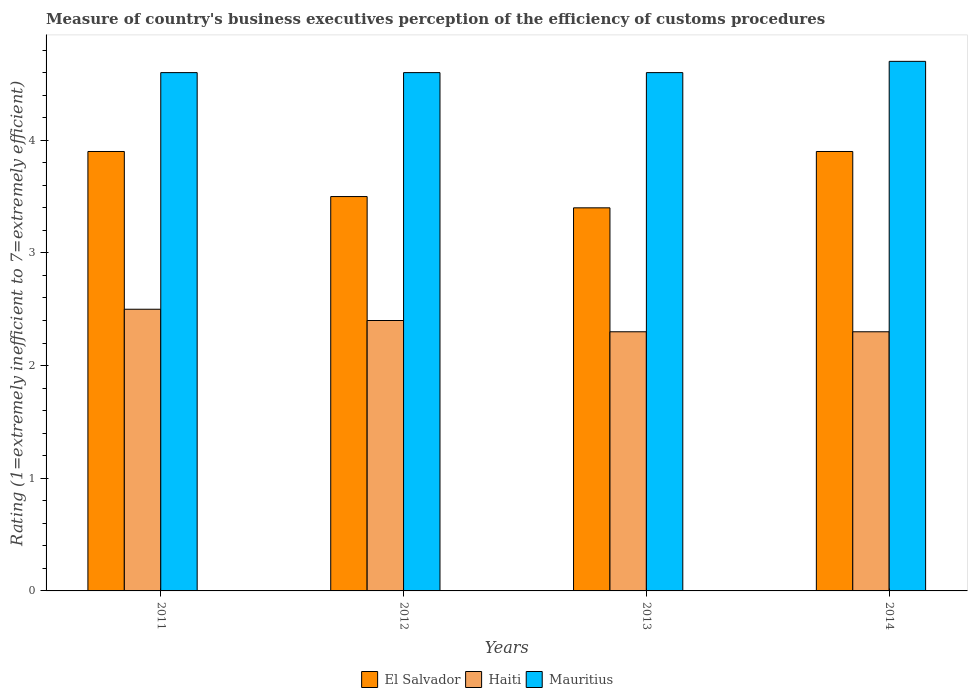How many different coloured bars are there?
Your response must be concise. 3. How many groups of bars are there?
Ensure brevity in your answer.  4. What is the label of the 2nd group of bars from the left?
Provide a short and direct response. 2012. In how many cases, is the number of bars for a given year not equal to the number of legend labels?
Your response must be concise. 0. What is the rating of the efficiency of customs procedure in Haiti in 2014?
Offer a terse response. 2.3. Across all years, what is the maximum rating of the efficiency of customs procedure in El Salvador?
Give a very brief answer. 3.9. In which year was the rating of the efficiency of customs procedure in El Salvador minimum?
Provide a succinct answer. 2013. What is the total rating of the efficiency of customs procedure in El Salvador in the graph?
Offer a terse response. 14.7. What is the difference between the rating of the efficiency of customs procedure in El Salvador in 2012 and that in 2014?
Provide a short and direct response. -0.4. What is the difference between the rating of the efficiency of customs procedure in Mauritius in 2012 and the rating of the efficiency of customs procedure in El Salvador in 2013?
Provide a succinct answer. 1.2. What is the average rating of the efficiency of customs procedure in El Salvador per year?
Your response must be concise. 3.68. In the year 2013, what is the difference between the rating of the efficiency of customs procedure in Haiti and rating of the efficiency of customs procedure in Mauritius?
Provide a succinct answer. -2.3. In how many years, is the rating of the efficiency of customs procedure in Haiti greater than 1.2?
Give a very brief answer. 4. What is the ratio of the rating of the efficiency of customs procedure in Haiti in 2012 to that in 2014?
Your response must be concise. 1.04. Is the rating of the efficiency of customs procedure in Haiti in 2011 less than that in 2012?
Ensure brevity in your answer.  No. Is the difference between the rating of the efficiency of customs procedure in Haiti in 2013 and 2014 greater than the difference between the rating of the efficiency of customs procedure in Mauritius in 2013 and 2014?
Ensure brevity in your answer.  Yes. What is the difference between the highest and the lowest rating of the efficiency of customs procedure in Haiti?
Provide a succinct answer. 0.2. Is the sum of the rating of the efficiency of customs procedure in El Salvador in 2012 and 2013 greater than the maximum rating of the efficiency of customs procedure in Haiti across all years?
Ensure brevity in your answer.  Yes. What does the 1st bar from the left in 2014 represents?
Offer a terse response. El Salvador. What does the 3rd bar from the right in 2011 represents?
Provide a succinct answer. El Salvador. How many years are there in the graph?
Give a very brief answer. 4. What is the difference between two consecutive major ticks on the Y-axis?
Your answer should be very brief. 1. Are the values on the major ticks of Y-axis written in scientific E-notation?
Give a very brief answer. No. Does the graph contain any zero values?
Make the answer very short. No. Does the graph contain grids?
Provide a short and direct response. No. What is the title of the graph?
Give a very brief answer. Measure of country's business executives perception of the efficiency of customs procedures. What is the label or title of the Y-axis?
Offer a very short reply. Rating (1=extremely inefficient to 7=extremely efficient). What is the Rating (1=extremely inefficient to 7=extremely efficient) of Mauritius in 2011?
Give a very brief answer. 4.6. What is the Rating (1=extremely inefficient to 7=extremely efficient) of Haiti in 2012?
Provide a succinct answer. 2.4. What is the Rating (1=extremely inefficient to 7=extremely efficient) in Mauritius in 2013?
Offer a terse response. 4.6. What is the Rating (1=extremely inefficient to 7=extremely efficient) of Haiti in 2014?
Give a very brief answer. 2.3. Across all years, what is the maximum Rating (1=extremely inefficient to 7=extremely efficient) of El Salvador?
Your answer should be very brief. 3.9. Across all years, what is the maximum Rating (1=extremely inefficient to 7=extremely efficient) of Haiti?
Provide a succinct answer. 2.5. Across all years, what is the maximum Rating (1=extremely inefficient to 7=extremely efficient) in Mauritius?
Your answer should be very brief. 4.7. Across all years, what is the minimum Rating (1=extremely inefficient to 7=extremely efficient) of El Salvador?
Your answer should be compact. 3.4. What is the total Rating (1=extremely inefficient to 7=extremely efficient) of Mauritius in the graph?
Ensure brevity in your answer.  18.5. What is the difference between the Rating (1=extremely inefficient to 7=extremely efficient) in El Salvador in 2011 and that in 2012?
Give a very brief answer. 0.4. What is the difference between the Rating (1=extremely inefficient to 7=extremely efficient) of Haiti in 2011 and that in 2012?
Make the answer very short. 0.1. What is the difference between the Rating (1=extremely inefficient to 7=extremely efficient) of Mauritius in 2011 and that in 2012?
Provide a short and direct response. 0. What is the difference between the Rating (1=extremely inefficient to 7=extremely efficient) of El Salvador in 2011 and that in 2013?
Provide a short and direct response. 0.5. What is the difference between the Rating (1=extremely inefficient to 7=extremely efficient) of Haiti in 2011 and that in 2013?
Keep it short and to the point. 0.2. What is the difference between the Rating (1=extremely inefficient to 7=extremely efficient) in Mauritius in 2011 and that in 2013?
Ensure brevity in your answer.  0. What is the difference between the Rating (1=extremely inefficient to 7=extremely efficient) of Haiti in 2011 and that in 2014?
Offer a terse response. 0.2. What is the difference between the Rating (1=extremely inefficient to 7=extremely efficient) of Mauritius in 2012 and that in 2013?
Provide a short and direct response. 0. What is the difference between the Rating (1=extremely inefficient to 7=extremely efficient) in El Salvador in 2012 and that in 2014?
Offer a terse response. -0.4. What is the difference between the Rating (1=extremely inefficient to 7=extremely efficient) in Haiti in 2012 and that in 2014?
Your response must be concise. 0.1. What is the difference between the Rating (1=extremely inefficient to 7=extremely efficient) in Haiti in 2013 and that in 2014?
Your answer should be compact. 0. What is the difference between the Rating (1=extremely inefficient to 7=extremely efficient) in El Salvador in 2011 and the Rating (1=extremely inefficient to 7=extremely efficient) in Mauritius in 2012?
Provide a succinct answer. -0.7. What is the difference between the Rating (1=extremely inefficient to 7=extremely efficient) in El Salvador in 2011 and the Rating (1=extremely inefficient to 7=extremely efficient) in Haiti in 2013?
Offer a terse response. 1.6. What is the difference between the Rating (1=extremely inefficient to 7=extremely efficient) in Haiti in 2011 and the Rating (1=extremely inefficient to 7=extremely efficient) in Mauritius in 2013?
Offer a very short reply. -2.1. What is the difference between the Rating (1=extremely inefficient to 7=extremely efficient) in El Salvador in 2011 and the Rating (1=extremely inefficient to 7=extremely efficient) in Mauritius in 2014?
Your answer should be very brief. -0.8. What is the difference between the Rating (1=extremely inefficient to 7=extremely efficient) of Haiti in 2011 and the Rating (1=extremely inefficient to 7=extremely efficient) of Mauritius in 2014?
Provide a short and direct response. -2.2. What is the difference between the Rating (1=extremely inefficient to 7=extremely efficient) in El Salvador in 2012 and the Rating (1=extremely inefficient to 7=extremely efficient) in Haiti in 2013?
Ensure brevity in your answer.  1.2. What is the difference between the Rating (1=extremely inefficient to 7=extremely efficient) in Haiti in 2012 and the Rating (1=extremely inefficient to 7=extremely efficient) in Mauritius in 2013?
Offer a very short reply. -2.2. What is the difference between the Rating (1=extremely inefficient to 7=extremely efficient) of El Salvador in 2012 and the Rating (1=extremely inefficient to 7=extremely efficient) of Haiti in 2014?
Make the answer very short. 1.2. What is the difference between the Rating (1=extremely inefficient to 7=extremely efficient) of El Salvador in 2012 and the Rating (1=extremely inefficient to 7=extremely efficient) of Mauritius in 2014?
Provide a short and direct response. -1.2. What is the difference between the Rating (1=extremely inefficient to 7=extremely efficient) in El Salvador in 2013 and the Rating (1=extremely inefficient to 7=extremely efficient) in Haiti in 2014?
Offer a terse response. 1.1. What is the difference between the Rating (1=extremely inefficient to 7=extremely efficient) in El Salvador in 2013 and the Rating (1=extremely inefficient to 7=extremely efficient) in Mauritius in 2014?
Your answer should be very brief. -1.3. What is the difference between the Rating (1=extremely inefficient to 7=extremely efficient) in Haiti in 2013 and the Rating (1=extremely inefficient to 7=extremely efficient) in Mauritius in 2014?
Ensure brevity in your answer.  -2.4. What is the average Rating (1=extremely inefficient to 7=extremely efficient) of El Salvador per year?
Give a very brief answer. 3.67. What is the average Rating (1=extremely inefficient to 7=extremely efficient) of Haiti per year?
Make the answer very short. 2.38. What is the average Rating (1=extremely inefficient to 7=extremely efficient) of Mauritius per year?
Ensure brevity in your answer.  4.62. In the year 2011, what is the difference between the Rating (1=extremely inefficient to 7=extremely efficient) of El Salvador and Rating (1=extremely inefficient to 7=extremely efficient) of Haiti?
Make the answer very short. 1.4. In the year 2012, what is the difference between the Rating (1=extremely inefficient to 7=extremely efficient) of El Salvador and Rating (1=extremely inefficient to 7=extremely efficient) of Haiti?
Provide a succinct answer. 1.1. In the year 2012, what is the difference between the Rating (1=extremely inefficient to 7=extremely efficient) of El Salvador and Rating (1=extremely inefficient to 7=extremely efficient) of Mauritius?
Give a very brief answer. -1.1. In the year 2012, what is the difference between the Rating (1=extremely inefficient to 7=extremely efficient) in Haiti and Rating (1=extremely inefficient to 7=extremely efficient) in Mauritius?
Your answer should be compact. -2.2. In the year 2013, what is the difference between the Rating (1=extremely inefficient to 7=extremely efficient) in El Salvador and Rating (1=extremely inefficient to 7=extremely efficient) in Mauritius?
Offer a terse response. -1.2. In the year 2013, what is the difference between the Rating (1=extremely inefficient to 7=extremely efficient) in Haiti and Rating (1=extremely inefficient to 7=extremely efficient) in Mauritius?
Provide a short and direct response. -2.3. In the year 2014, what is the difference between the Rating (1=extremely inefficient to 7=extremely efficient) of El Salvador and Rating (1=extremely inefficient to 7=extremely efficient) of Mauritius?
Ensure brevity in your answer.  -0.8. In the year 2014, what is the difference between the Rating (1=extremely inefficient to 7=extremely efficient) in Haiti and Rating (1=extremely inefficient to 7=extremely efficient) in Mauritius?
Offer a very short reply. -2.4. What is the ratio of the Rating (1=extremely inefficient to 7=extremely efficient) in El Salvador in 2011 to that in 2012?
Provide a short and direct response. 1.11. What is the ratio of the Rating (1=extremely inefficient to 7=extremely efficient) of Haiti in 2011 to that in 2012?
Make the answer very short. 1.04. What is the ratio of the Rating (1=extremely inefficient to 7=extremely efficient) in Mauritius in 2011 to that in 2012?
Your response must be concise. 1. What is the ratio of the Rating (1=extremely inefficient to 7=extremely efficient) of El Salvador in 2011 to that in 2013?
Ensure brevity in your answer.  1.15. What is the ratio of the Rating (1=extremely inefficient to 7=extremely efficient) of Haiti in 2011 to that in 2013?
Offer a very short reply. 1.09. What is the ratio of the Rating (1=extremely inefficient to 7=extremely efficient) of Mauritius in 2011 to that in 2013?
Your response must be concise. 1. What is the ratio of the Rating (1=extremely inefficient to 7=extremely efficient) in Haiti in 2011 to that in 2014?
Ensure brevity in your answer.  1.09. What is the ratio of the Rating (1=extremely inefficient to 7=extremely efficient) in Mauritius in 2011 to that in 2014?
Your answer should be compact. 0.98. What is the ratio of the Rating (1=extremely inefficient to 7=extremely efficient) in El Salvador in 2012 to that in 2013?
Provide a succinct answer. 1.03. What is the ratio of the Rating (1=extremely inefficient to 7=extremely efficient) in Haiti in 2012 to that in 2013?
Make the answer very short. 1.04. What is the ratio of the Rating (1=extremely inefficient to 7=extremely efficient) in El Salvador in 2012 to that in 2014?
Your answer should be very brief. 0.9. What is the ratio of the Rating (1=extremely inefficient to 7=extremely efficient) of Haiti in 2012 to that in 2014?
Offer a very short reply. 1.04. What is the ratio of the Rating (1=extremely inefficient to 7=extremely efficient) in Mauritius in 2012 to that in 2014?
Offer a terse response. 0.98. What is the ratio of the Rating (1=extremely inefficient to 7=extremely efficient) in El Salvador in 2013 to that in 2014?
Offer a terse response. 0.87. What is the ratio of the Rating (1=extremely inefficient to 7=extremely efficient) in Mauritius in 2013 to that in 2014?
Make the answer very short. 0.98. What is the difference between the highest and the lowest Rating (1=extremely inefficient to 7=extremely efficient) in Haiti?
Provide a succinct answer. 0.2. 